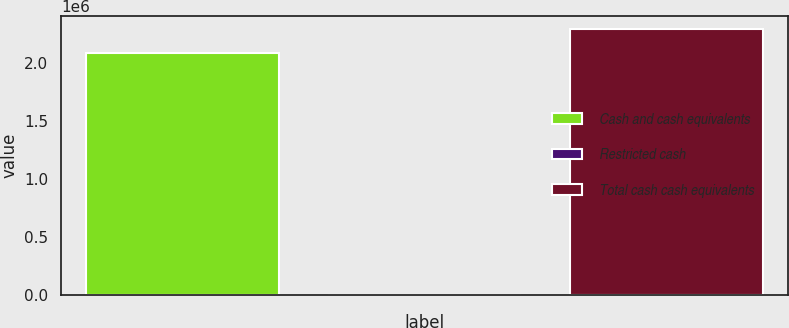Convert chart. <chart><loc_0><loc_0><loc_500><loc_500><bar_chart><fcel>Cash and cash equivalents<fcel>Restricted cash<fcel>Total cash cash equivalents<nl><fcel>2.08108e+06<fcel>932<fcel>2.28918e+06<nl></chart> 